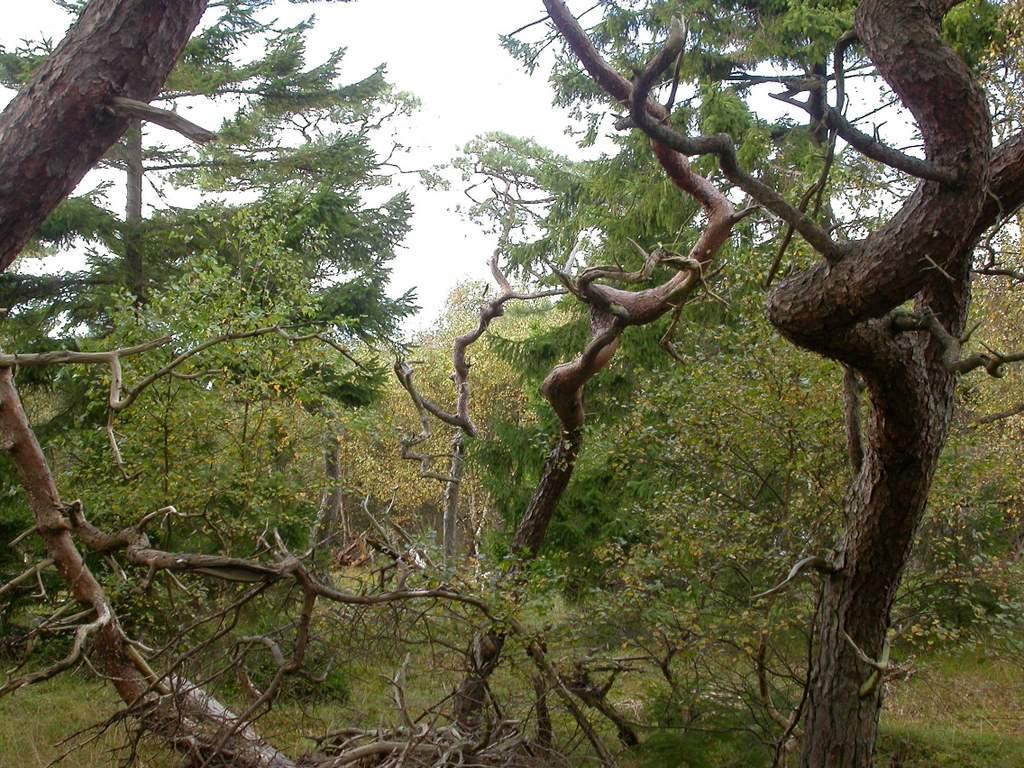How would you summarize this image in a sentence or two? In this image I can see trees in green color, background the sky is in white color. 